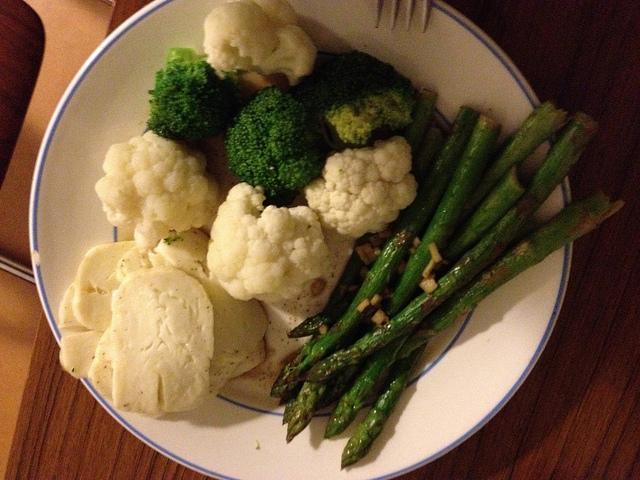How many pieces of cauliflower are in this pan?
Give a very brief answer. 4. How many different types of vegetable are there?
Give a very brief answer. 3. How many broccolis are in the photo?
Give a very brief answer. 3. How many black cars are setting near the pillar?
Give a very brief answer. 0. 